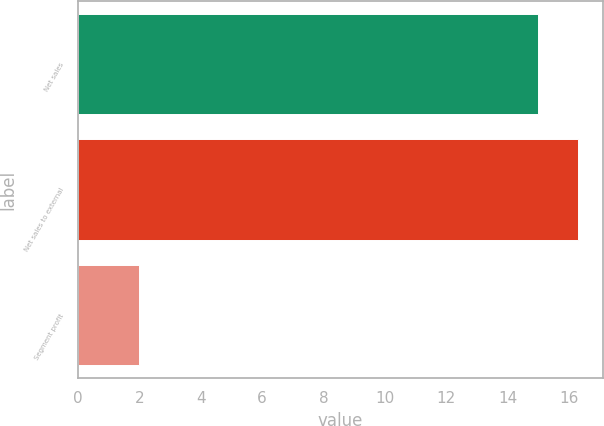Convert chart to OTSL. <chart><loc_0><loc_0><loc_500><loc_500><bar_chart><fcel>Net sales<fcel>Net sales to external<fcel>Segment profit<nl><fcel>15<fcel>16.3<fcel>2<nl></chart> 